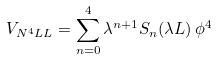Convert formula to latex. <formula><loc_0><loc_0><loc_500><loc_500>V _ { N ^ { 4 } L L } = \sum ^ { 4 } _ { n = 0 } \lambda ^ { n + 1 } S _ { n } ( \lambda L ) \, \phi ^ { 4 }</formula> 